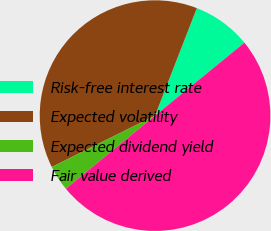<chart> <loc_0><loc_0><loc_500><loc_500><pie_chart><fcel>Risk-free interest rate<fcel>Expected volatility<fcel>Expected dividend yield<fcel>Fair value derived<nl><fcel>8.21%<fcel>38.24%<fcel>3.58%<fcel>49.96%<nl></chart> 